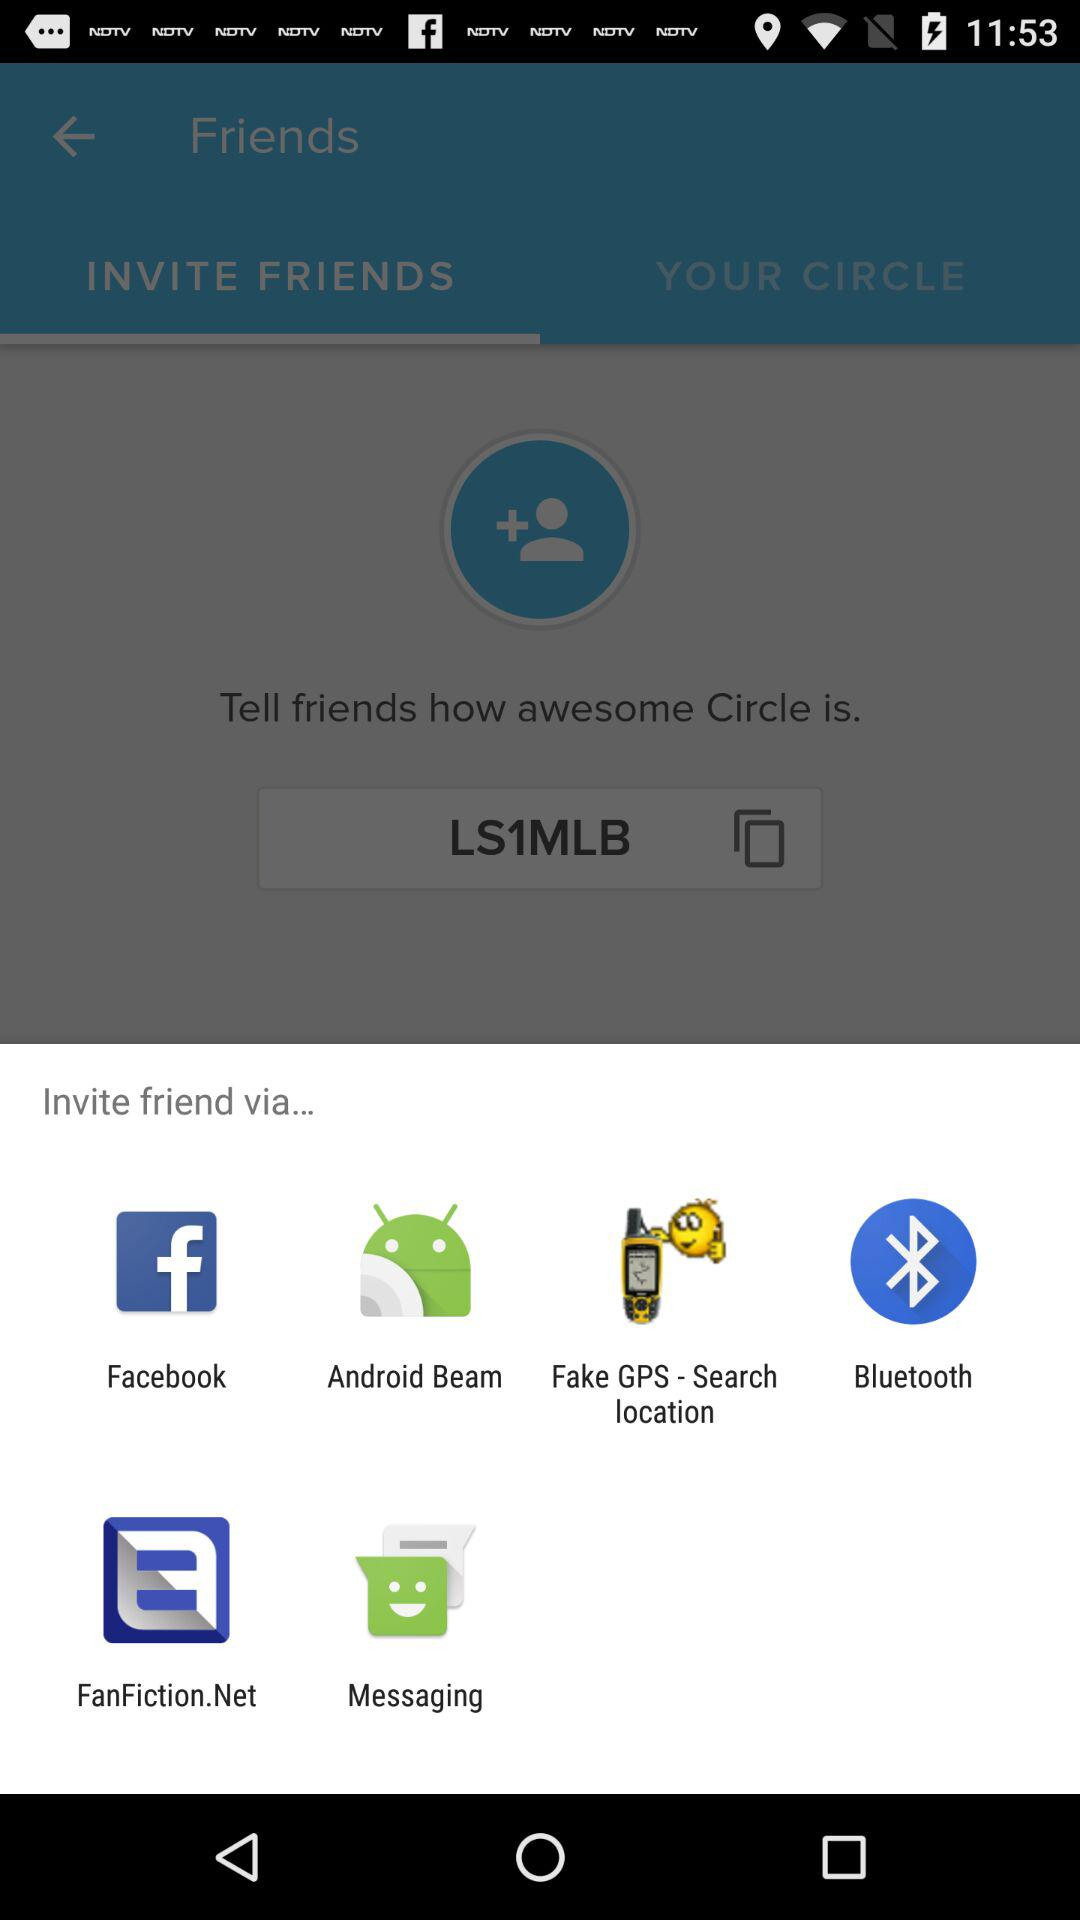What are the different options available to invite friends? The different options are "Facebook", "Android Beam", "Fake GPS Search location", "Bluetooth", "FanFiction.Net" and "Messaging". 